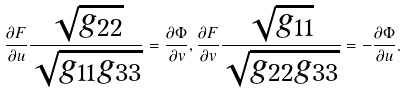Convert formula to latex. <formula><loc_0><loc_0><loc_500><loc_500>\frac { \partial F } { \partial u } \frac { \sqrt { g _ { 2 2 } } } { \sqrt { g _ { 1 1 } g _ { 3 3 } } } = \frac { \partial \Phi } { \partial v } , \frac { \partial F } { \partial v } \frac { \sqrt { g _ { 1 1 } } } { \sqrt { g _ { 2 2 } g _ { 3 3 } } } = - \frac { \partial \Phi } { \partial u } .</formula> 